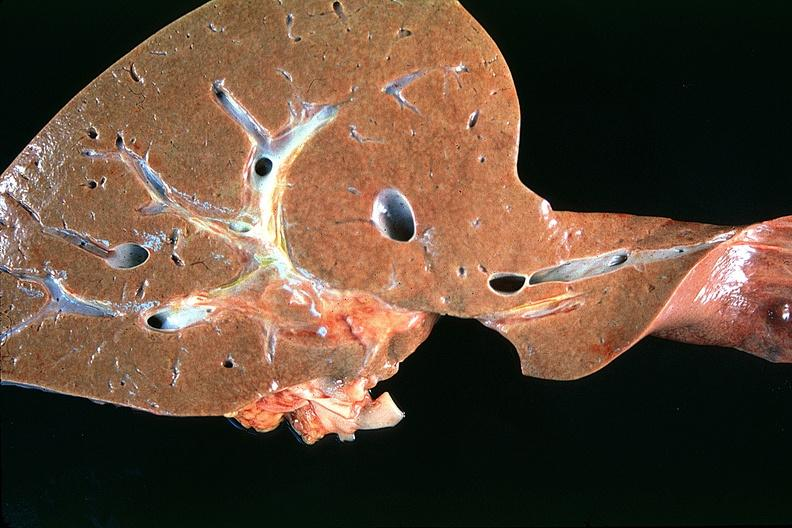what does this image show?
Answer the question using a single word or phrase. Normal liver 